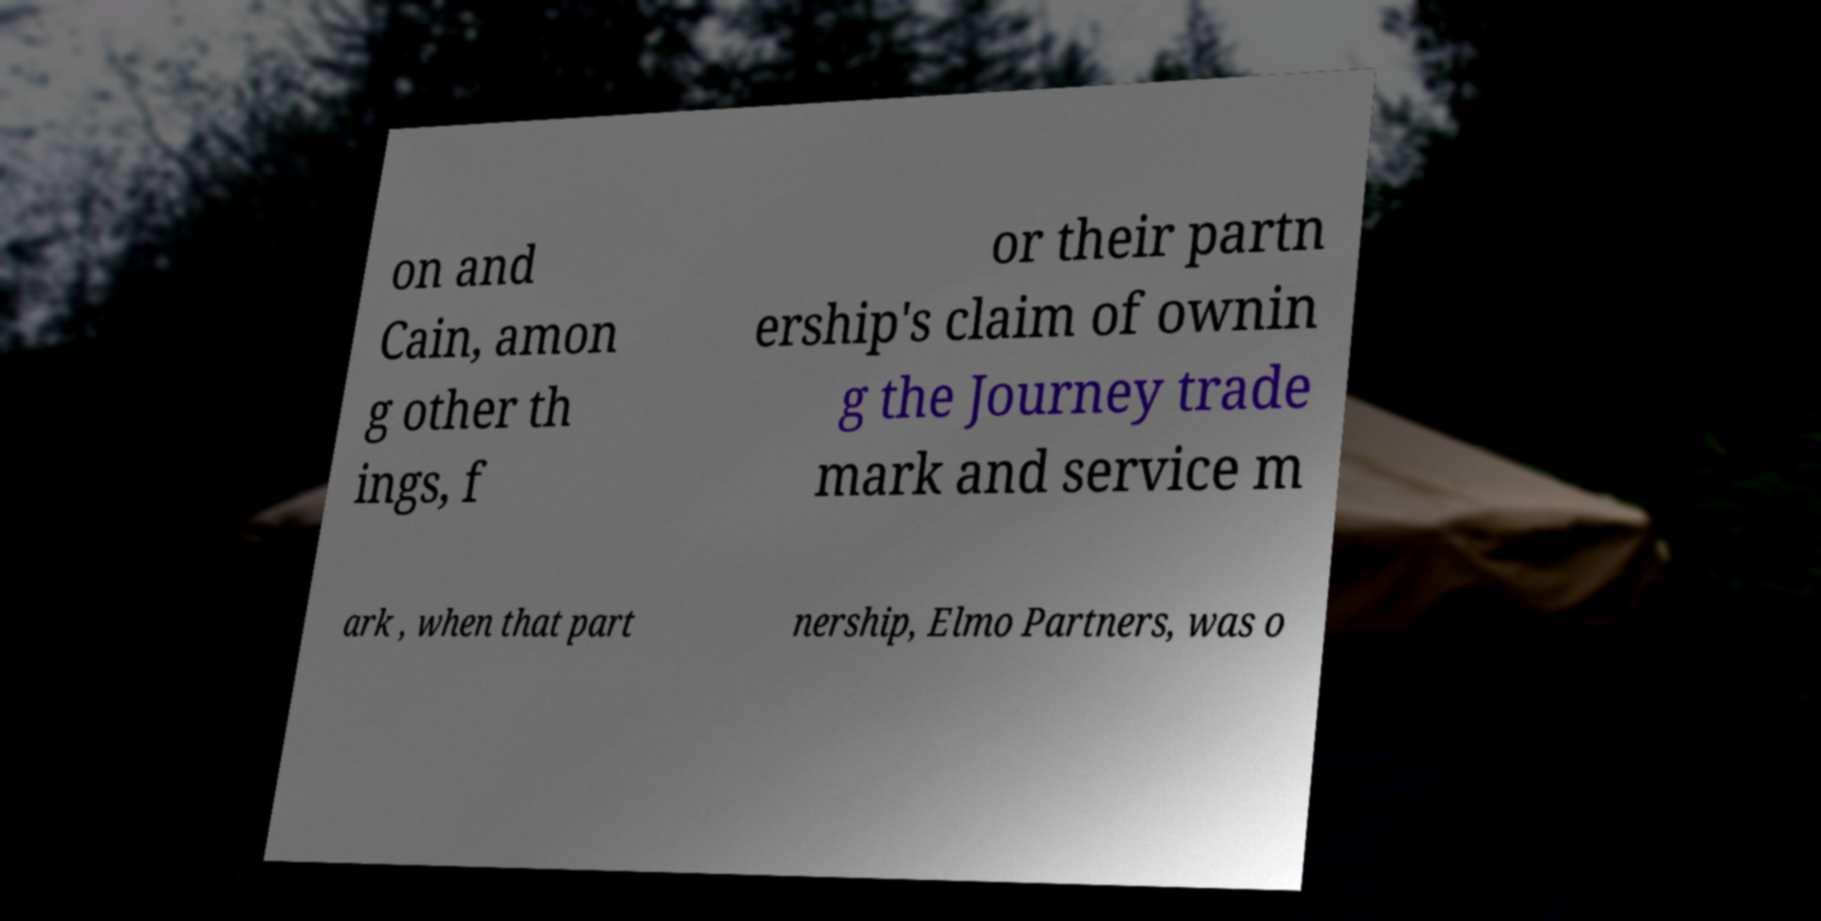Could you assist in decoding the text presented in this image and type it out clearly? on and Cain, amon g other th ings, f or their partn ership's claim of ownin g the Journey trade mark and service m ark , when that part nership, Elmo Partners, was o 